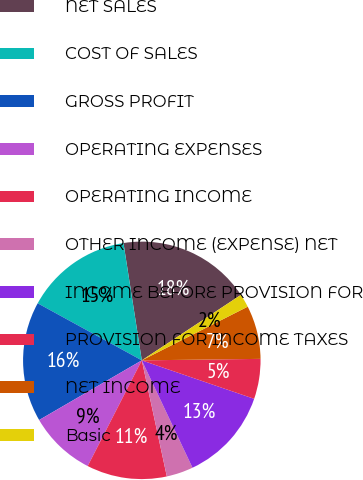<chart> <loc_0><loc_0><loc_500><loc_500><pie_chart><fcel>NET SALES<fcel>COST OF SALES<fcel>GROSS PROFIT<fcel>OPERATING EXPENSES<fcel>OPERATING INCOME<fcel>OTHER INCOME (EXPENSE) NET<fcel>INCOME BEFORE PROVISION FOR<fcel>PROVISION FOR INCOME TAXES<fcel>NET INCOME<fcel>Basic<nl><fcel>18.18%<fcel>14.55%<fcel>16.36%<fcel>9.09%<fcel>10.91%<fcel>3.64%<fcel>12.73%<fcel>5.45%<fcel>7.27%<fcel>1.82%<nl></chart> 